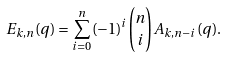<formula> <loc_0><loc_0><loc_500><loc_500>E _ { k , n } ( q ) = \sum _ { i = 0 } ^ { n } ( - 1 ) ^ { i } { n \choose i } A _ { k , n - i } ( q ) .</formula> 